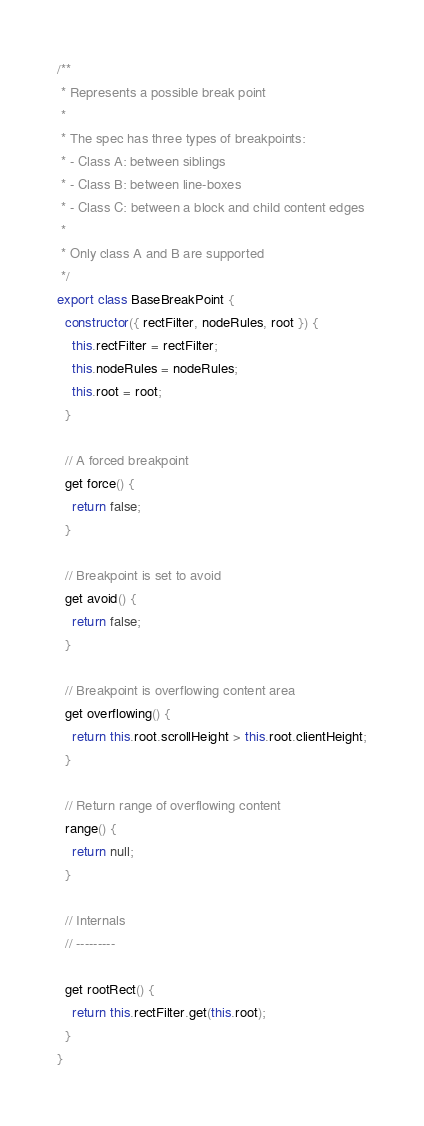Convert code to text. <code><loc_0><loc_0><loc_500><loc_500><_JavaScript_>/**
 * Represents a possible break point
 *
 * The spec has three types of breakpoints:
 * - Class A: between siblings
 * - Class B: between line-boxes
 * - Class C: between a block and child content edges
 *
 * Only class A and B are supported
 */
export class BaseBreakPoint {
  constructor({ rectFilter, nodeRules, root }) {
    this.rectFilter = rectFilter;
    this.nodeRules = nodeRules;
    this.root = root;
  }

  // A forced breakpoint
  get force() {
    return false;
  }

  // Breakpoint is set to avoid
  get avoid() {
    return false;
  }

  // Breakpoint is overflowing content area
  get overflowing() {
    return this.root.scrollHeight > this.root.clientHeight;
  }

  // Return range of overflowing content
  range() {
    return null;
  }

  // Internals
  // ---------

  get rootRect() {
    return this.rectFilter.get(this.root);
  }
}
</code> 